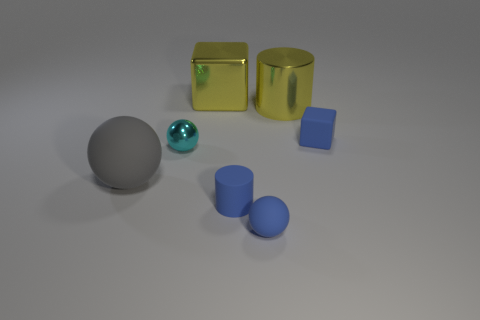What size is the cylinder behind the large gray sphere?
Your response must be concise. Large. Is there a blue metal cylinder that has the same size as the cyan object?
Make the answer very short. No. Do the blue matte thing that is behind the cyan metal object and the big matte ball have the same size?
Offer a terse response. No. How big is the cyan ball?
Provide a succinct answer. Small. What color is the rubber object behind the metal thing that is in front of the small rubber thing that is behind the gray rubber thing?
Make the answer very short. Blue. There is a cylinder in front of the tiny shiny sphere; is it the same color as the matte cube?
Make the answer very short. Yes. How many things are both in front of the large metallic block and to the left of the blue rubber cube?
Ensure brevity in your answer.  5. There is a blue rubber thing that is the same shape as the tiny cyan thing; what size is it?
Keep it short and to the point. Small. What number of things are in front of the cyan metallic ball that is in front of the block that is behind the tiny blue matte cube?
Offer a terse response. 3. What is the color of the matte thing in front of the cylinder in front of the small metallic thing?
Offer a terse response. Blue. 